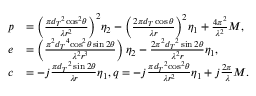<formula> <loc_0><loc_0><loc_500><loc_500>\begin{array} { r l } { p } & { = { { \left ( { \frac { { \pi { { d _ { T } } ^ { 2 } } { { \cos } ^ { 2 } } \theta } } { { \lambda { r ^ { 2 } } } } } \right ) } ^ { 2 } } { \eta _ { 2 } } - { { \left ( { \frac { { 2 \pi { d _ { T } } \cos \theta } } { \lambda r } } \right ) } ^ { 2 } } { \eta _ { 1 } } + \frac { { 4 { \pi ^ { 2 } } } } { { { \lambda ^ { 2 } } } } M , } \\ { e } & { = \left ( { \frac { { { \pi ^ { 2 } } { { d _ { T } } ^ { 4 } } { { \cos } ^ { 2 } } \theta \sin 2 \theta } } { { { \lambda ^ { 2 } } { r ^ { 3 } } } } } \right ) { \eta _ { 2 } } - \frac { { 2 { \pi ^ { 2 } } { { d _ { T } } ^ { 2 } } \sin 2 \theta } } { { { \lambda ^ { 2 } } r } } { \eta _ { 1 } } , } \\ { c } & { = - j \frac { { \pi { { d _ { T } } ^ { 2 } } \sin 2 \theta } } { \lambda r } { \eta _ { 1 } } , q = - j \frac { { \pi { { d _ { T } } ^ { 2 } } { { \cos } ^ { 2 } } \theta } } { { \lambda { r ^ { 2 } } } } { \eta _ { 1 } } + j \frac { 2 \pi } { \lambda } M . } \end{array}</formula> 